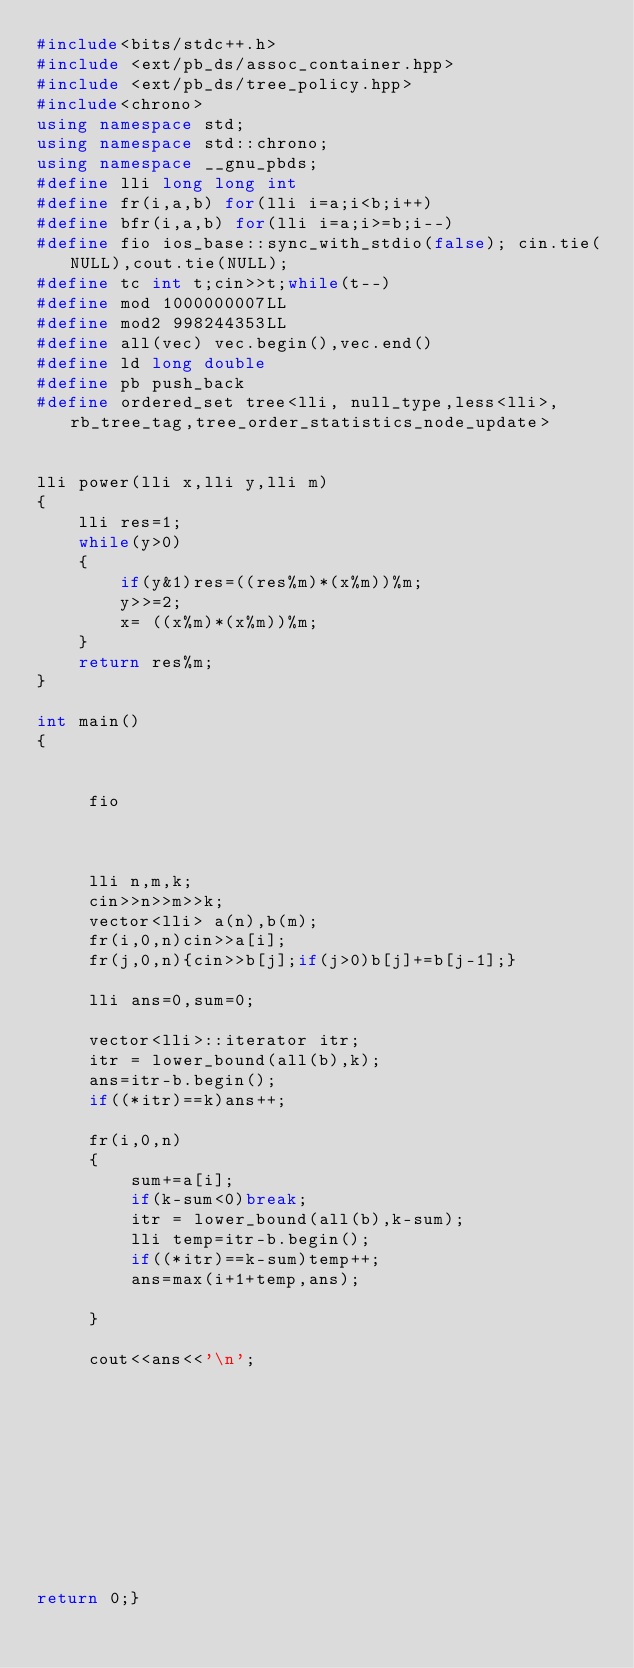Convert code to text. <code><loc_0><loc_0><loc_500><loc_500><_C++_>#include<bits/stdc++.h>
#include <ext/pb_ds/assoc_container.hpp> 
#include <ext/pb_ds/tree_policy.hpp> 
#include<chrono>
using namespace std;
using namespace std::chrono;
using namespace __gnu_pbds; 
#define lli long long int
#define fr(i,a,b) for(lli i=a;i<b;i++)
#define bfr(i,a,b) for(lli i=a;i>=b;i--)
#define fio ios_base::sync_with_stdio(false); cin.tie(NULL),cout.tie(NULL);
#define tc int t;cin>>t;while(t--)
#define mod 1000000007LL
#define mod2 998244353LL
#define all(vec) vec.begin(),vec.end()  
#define ld long double
#define pb push_back
#define ordered_set tree<lli, null_type,less<lli>, rb_tree_tag,tree_order_statistics_node_update> 


lli power(lli x,lli y,lli m)
{
    lli res=1;
    while(y>0)
    {
        if(y&1)res=((res%m)*(x%m))%m;
        y>>=2;
        x= ((x%m)*(x%m))%m;
    }
    return res%m;
}

int main()
{
    
                        
     fio

     
    
     lli n,m,k;
     cin>>n>>m>>k;
     vector<lli> a(n),b(m);
     fr(i,0,n)cin>>a[i];
     fr(j,0,n){cin>>b[j];if(j>0)b[j]+=b[j-1];}

     lli ans=0,sum=0;

     vector<lli>::iterator itr;
     itr = lower_bound(all(b),k);
     ans=itr-b.begin();
     if((*itr)==k)ans++;

     fr(i,0,n)
     {
         sum+=a[i];
         if(k-sum<0)break;
         itr = lower_bound(all(b),k-sum);
         lli temp=itr-b.begin();
         if((*itr)==k-sum)temp++;
         ans=max(i+1+temp,ans);

     }

     cout<<ans<<'\n';




      
     

     
              


return 0;}    
</code> 